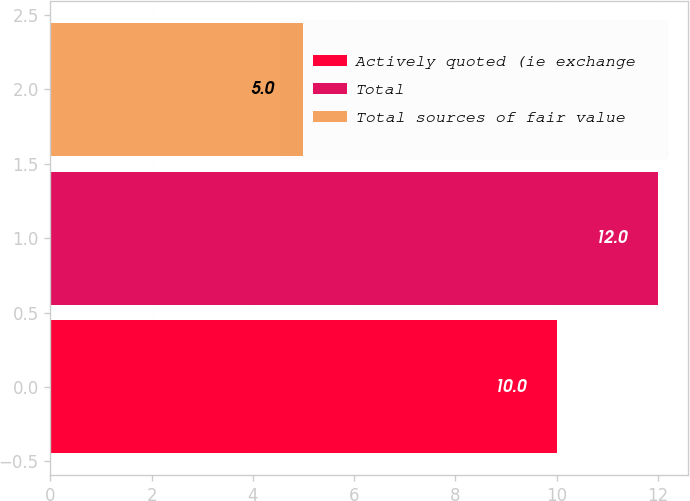Convert chart. <chart><loc_0><loc_0><loc_500><loc_500><bar_chart><fcel>Actively quoted (ie exchange<fcel>Total<fcel>Total sources of fair value<nl><fcel>10<fcel>12<fcel>5<nl></chart> 